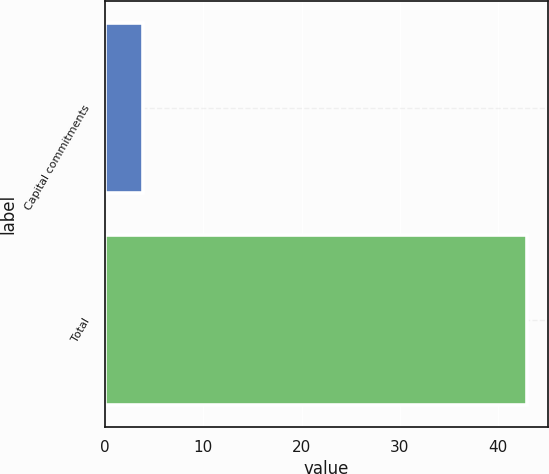Convert chart. <chart><loc_0><loc_0><loc_500><loc_500><bar_chart><fcel>Capital commitments<fcel>Total<nl><fcel>3.9<fcel>42.9<nl></chart> 